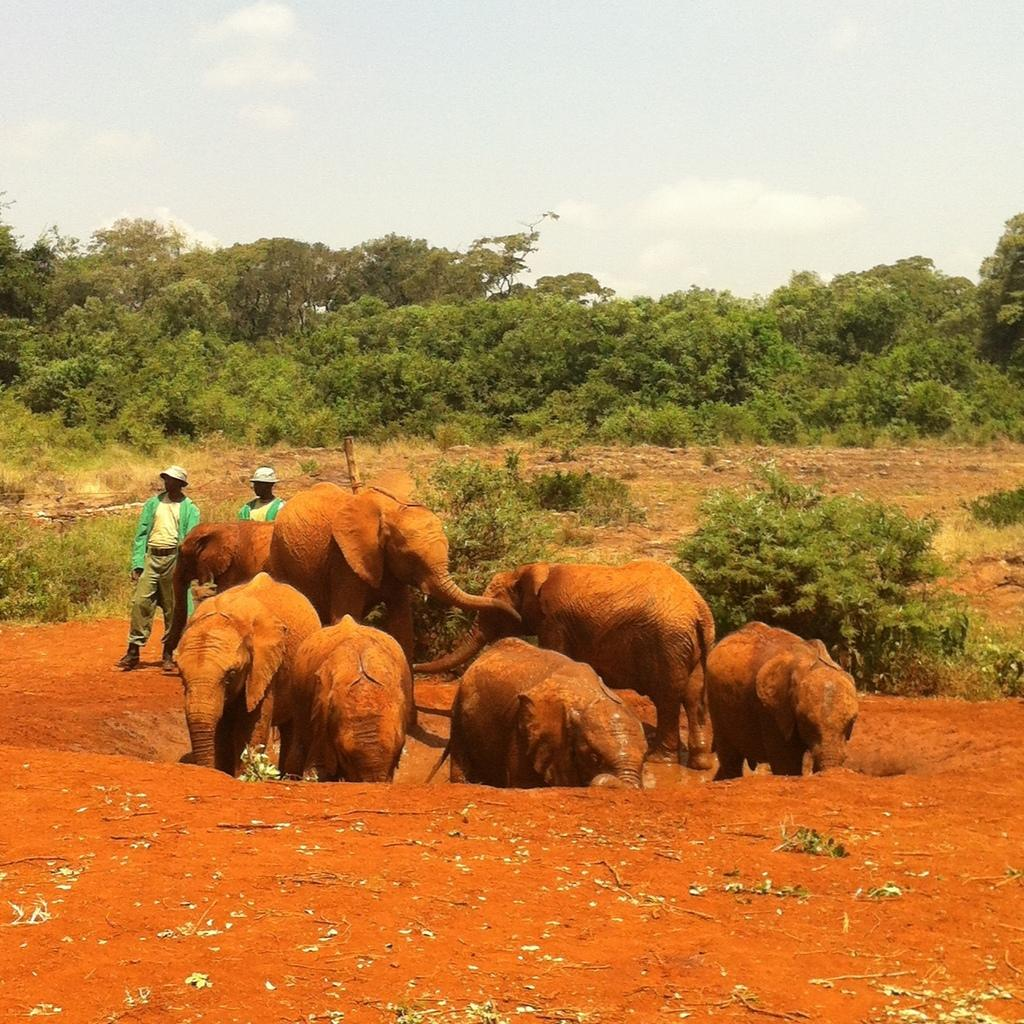What animals are present in the image? There is a herd of elephants in the image. Where are the two persons located in the image? The two persons are standing on the left side of the image. What can be seen in the background of the image? There are trees in the background of the image. What is visible in the sky in the image? The sky is visible in the image, and there are clouds in the sky. What type of angle is the boy using to approach the elephants in the image? There is no boy present in the image, so it is not possible to determine the angle at which he might approach the elephants. 